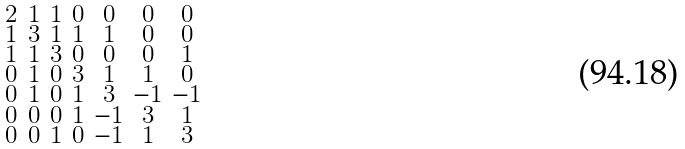Convert formula to latex. <formula><loc_0><loc_0><loc_500><loc_500>\begin{smallmatrix} 2 & 1 & 1 & 0 & 0 & 0 & 0 \\ 1 & 3 & 1 & 1 & 1 & 0 & 0 \\ 1 & 1 & 3 & 0 & 0 & 0 & 1 \\ 0 & 1 & 0 & 3 & 1 & 1 & 0 \\ 0 & 1 & 0 & 1 & 3 & - 1 & - 1 \\ 0 & 0 & 0 & 1 & - 1 & 3 & 1 \\ 0 & 0 & 1 & 0 & - 1 & 1 & 3 \end{smallmatrix}</formula> 